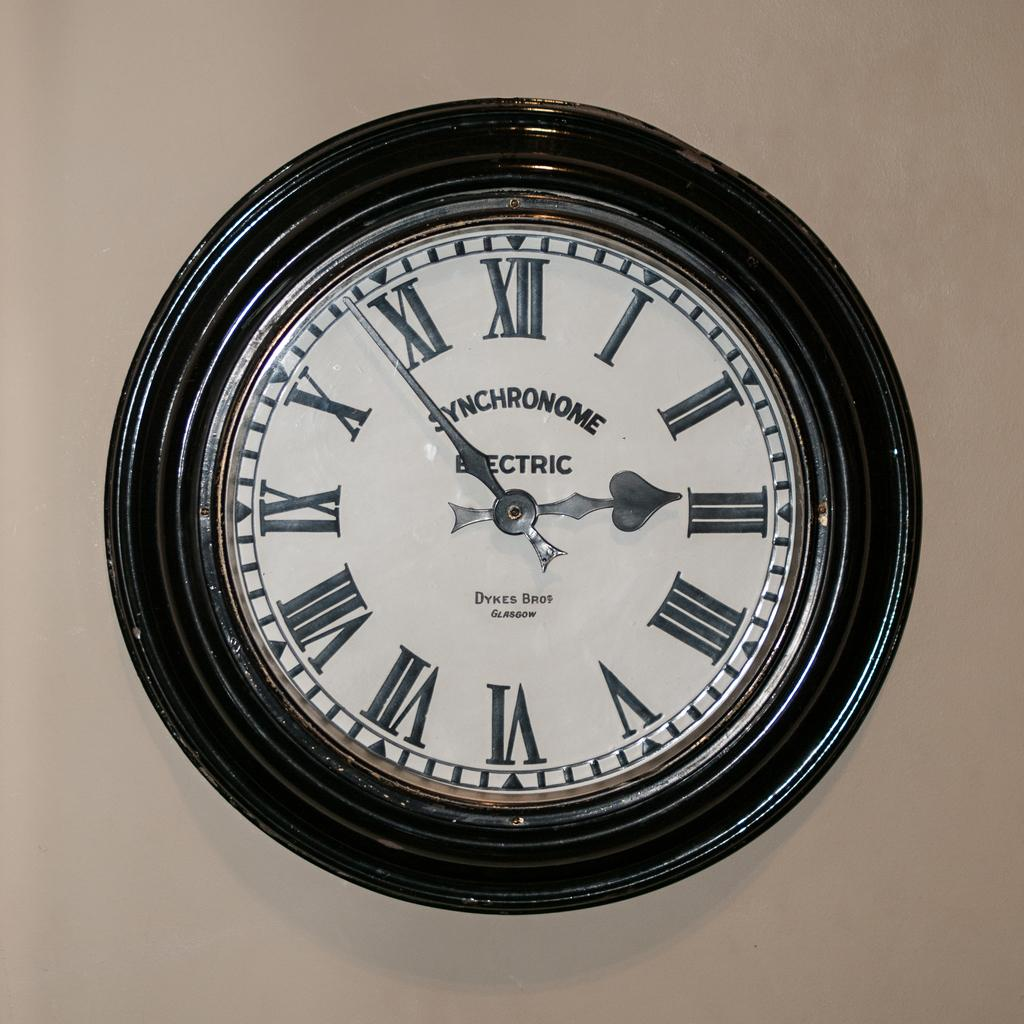<image>
Describe the image concisely. A synchronome electric wall clock on a beige wall 